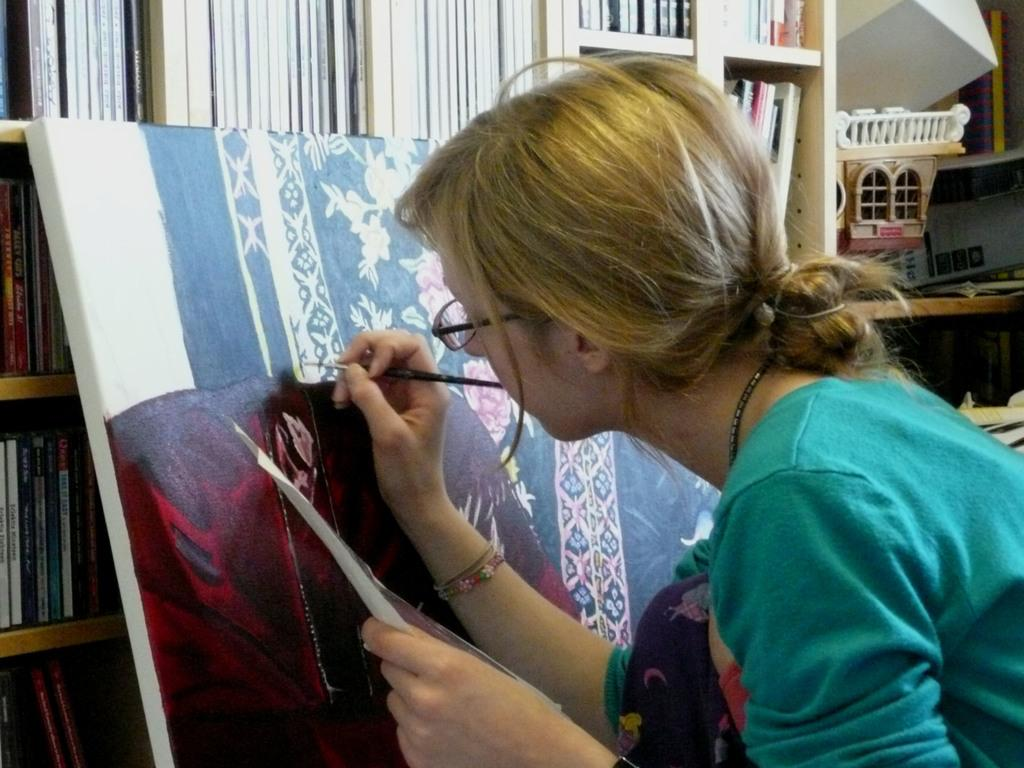Who is present in the image? There is a person in the image. What is the person wearing? The person is wearing clothes. What activity is the person engaged in? The person is painting on a board. What can be seen in the background of the image? There is a rack in the background of the image. What is stored on the rack? The rack contains books. What type of breakfast is the person eating in the image? There is no breakfast present in the image; the person is painting on a board. Can you see a van in the image? No, there is no van present in the image. 